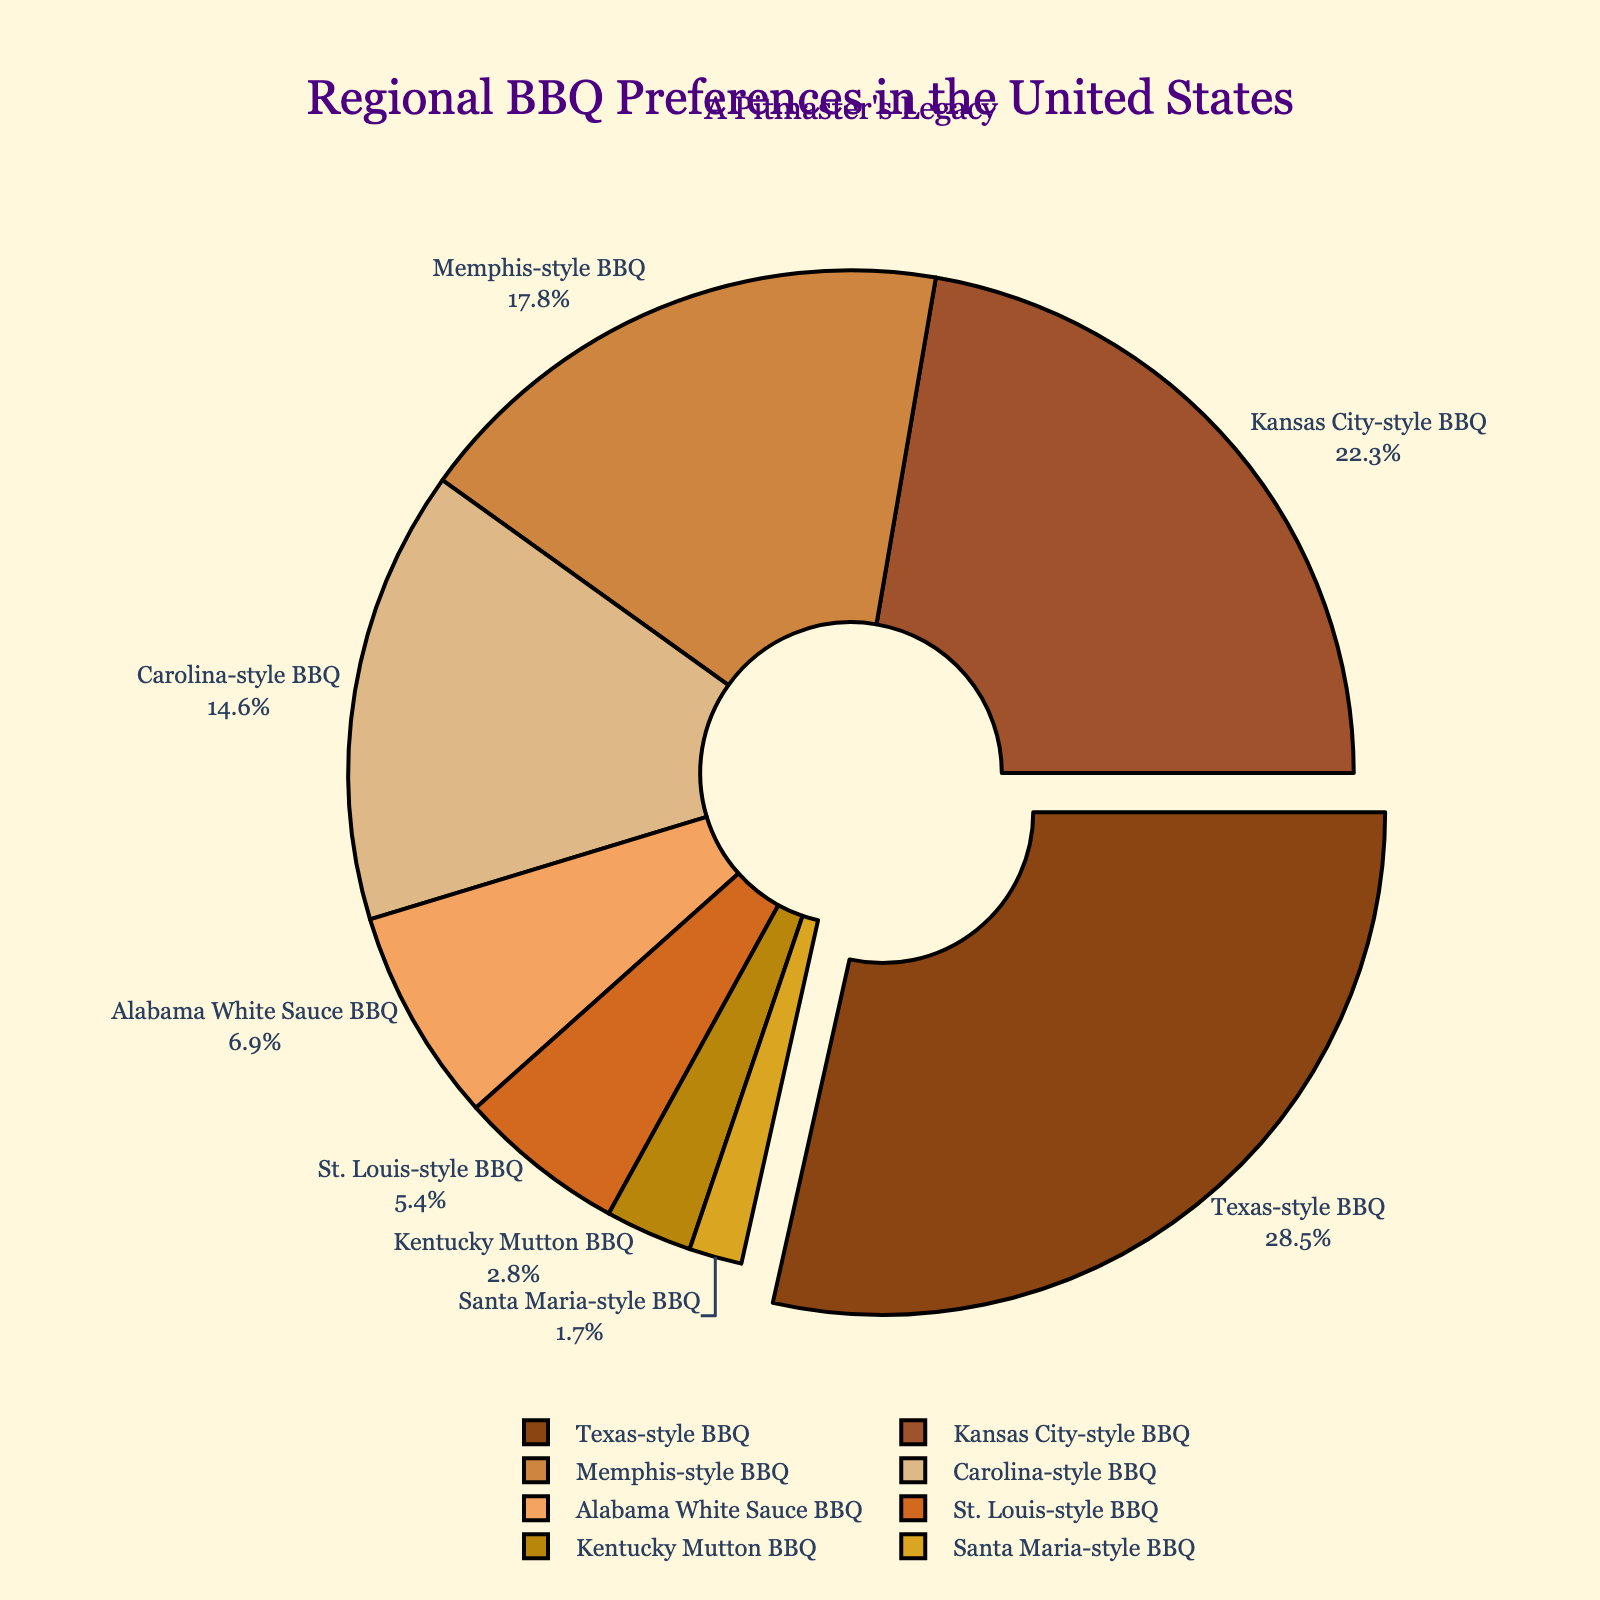what percentage of the market share is held by Texas-style and Kansas City-style BBQ combined? Add the market share of Texas-style BBQ (28.5%) and Kansas City-style BBQ (22.3%). So 28.5 + 22.3 = 50.8.
Answer: 50.8% Which BBQ style has the smallest market share? Look for the smallest value in the market share percentages, which is Santa Maria-style BBQ at 1.7%.
Answer: Santa Maria-style BBQ How does the market share of Carolina-style BBQ compare to Memphis-style BBQ? Compare the market share percentages of Carolina-style BBQ (14.6%) and Memphis-style BBQ (17.8%). Since 14.6 is less than 17.8, Carolina-style BBQ has a smaller market share than Memphis-style BBQ.
Answer: Carolina-style BBQ has a smaller market share Which BBQ style ranks third in market share? Look at the percentages and rank them from highest to lowest. The third highest is Memphis-style BBQ with 17.8%.
Answer: Memphis-style BBQ By how much does Kansas City-style BBQ's market share exceed Alabama White Sauce BBQ's market share? Subtract the market share percentage of Alabama White Sauce BBQ (6.9%) from Kansas City-style BBQ (22.3%). So, 22.3 - 6.9 = 15.4.
Answer: 15.4% What percentage of the total market does Kentucky Mutton BBQ and St. Louis-style BBQ share? Add the market share of Kentucky Mutton BBQ (2.8%) and St. Louis-style BBQ (5.4%). So, 2.8 + 5.4 = 8.2.
Answer: 8.2% Which BBQ style is represented by the largest slice of the pie chart? The largest slice pulls out and belongs to Texas-style BBQ with a market share of 28.5%.
Answer: Texas-style BBQ Is there a BBQ style whose market share is between 5% and 10%? Check the market share values. Alabama White Sauce BBQ (6.9%) and St. Louis-style BBQ (5.4%) both fall into this range.
Answer: Yes, Alabama White Sauce BBQ and St. Louis-style BBQ What is the combined market share of the four least popular BBQ styles? Add the market share percentages of the four styles with the lowest market shares: Alabama White Sauce BBQ (6.9%), St. Louis-style BBQ (5.4%), Kentucky Mutton BBQ (2.8%), and Santa Maria-style BBQ (1.7%). So, 6.9 + 5.4 + 2.8 + 1.7 = 16.8.
Answer: 16.8% How much more market share does Texas-style BBQ have compared to Santa Maria-style BBQ? Subtract the market share percentage of Santa Maria-style BBQ (1.7%) from Texas-style BBQ (28.5%). So, 28.5 - 1.7 = 26.8.
Answer: 26.8% 